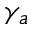<formula> <loc_0><loc_0><loc_500><loc_500>\gamma _ { a }</formula> 